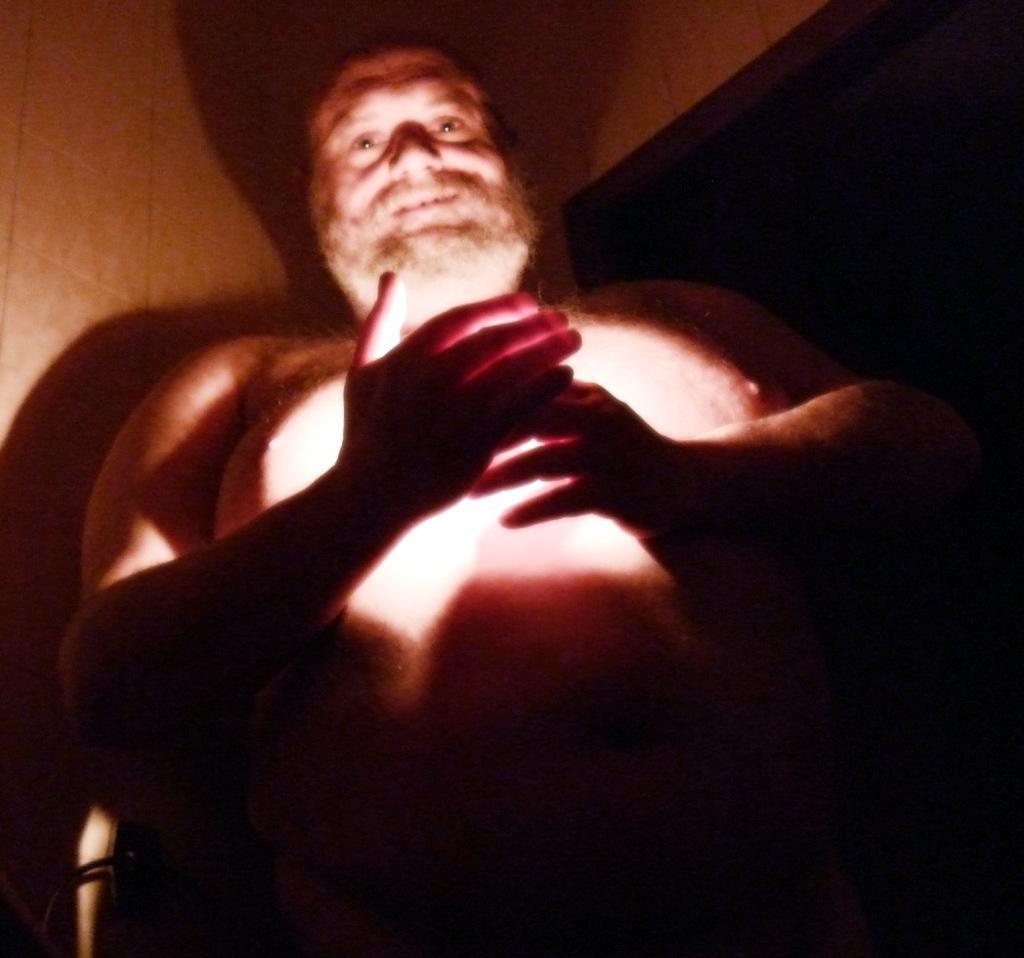Could you give a brief overview of what you see in this image? In this picture I can see a man standing, and in the background there is a wall. 